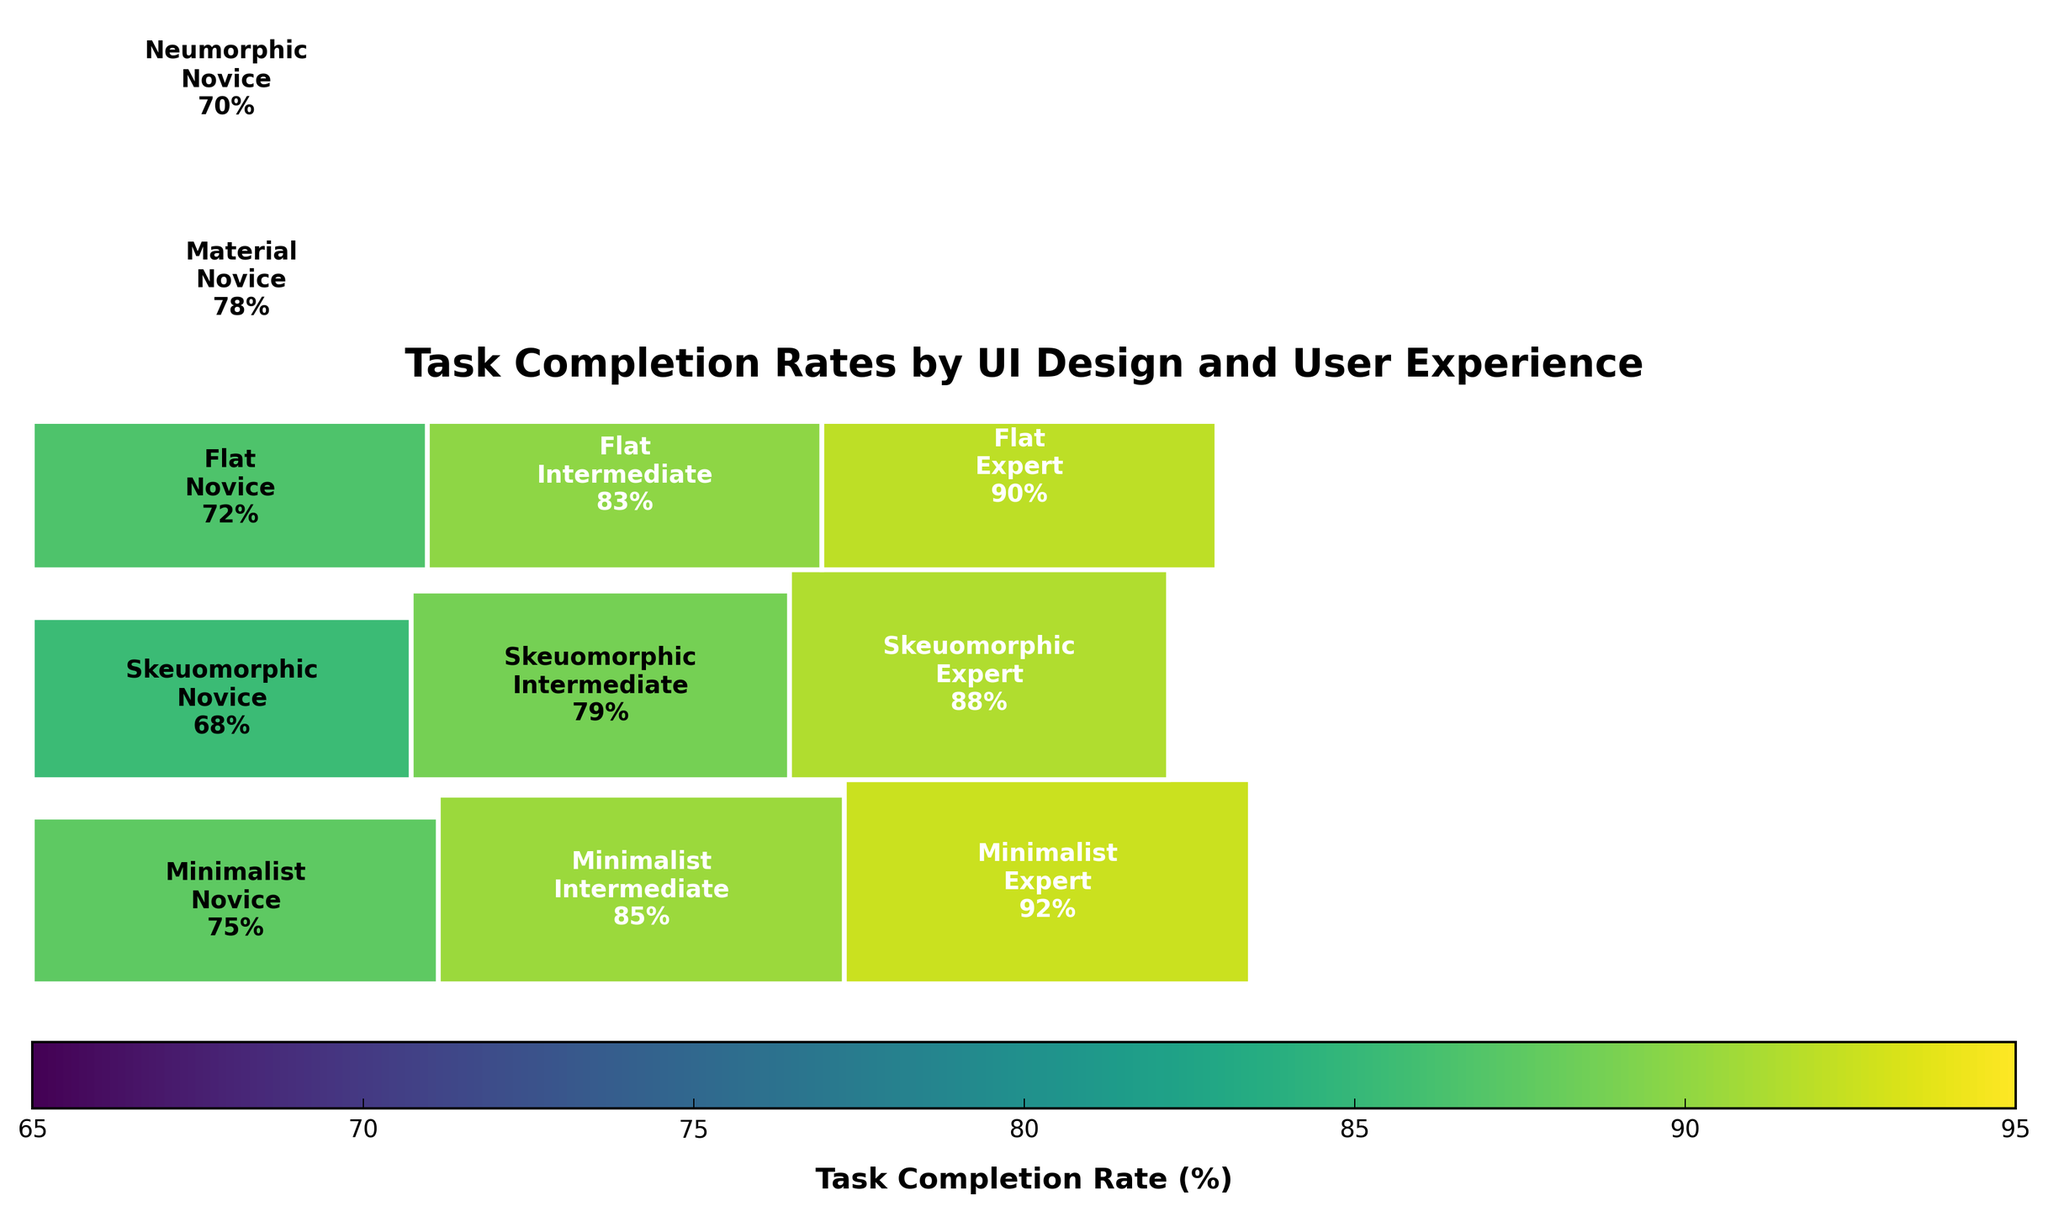What is the title of the mosaic plot? The title of the mosaic plot is displayed at the top of the figure. It helps the viewer understand what the plot is about. In this case, the title is "Task Completion Rates by UI Design and User Experience".
Answer: Task Completion Rates by UI Design and User Experience Which UI design shows the highest task completion rate for novices? To find the highest task completion rate for novices, look at the relevant sections for novice users across different UI designs and compare the values. In this plot, 'Material' has the highest rate for novices at 78%.
Answer: Material Compare the task completion rates for Expert users in Minimalist and Neumorphic UI designs. Which one is higher? Check the segments labeled 'Expert' within both 'Minimalist' and 'Neumorphic' UI designs to compare their task completion rates. Minimalist Experts have a rate of 92%, while Neumorphic Experts have a rate of 89%.
Answer: Minimalist What is the approximate difference in task completion rates between Novice and Expert users for the Skeuomorphic design? Look at the task completion rates of Novice and Expert users within the Skeuomorphic design. Subtract the Novice rate of 68% from the Expert rate of 88% to find the difference.
Answer: 20% Which category has the largest segment in the plot based on task completion rates? The largest segment can be identified by visually examining which rectangle covers the largest area in the plot. The 'Minimalist' design for 'Expert' users, with a task completion rate of 92%, appears largest.
Answer: Minimalist-Expert Is the task completion rate for Intermediate users higher in the Flat design or the Neumorphic design? Locate the 'Intermediate' user segments in both the Flat and Neumorphic designs. Compare their values directly; Flat design shows 83% and Neumorphic 81%.
Answer: Flat How does the task completion rate for Expert users in the Flat design compare to the Material design? Examine the 'Expert' segments in the Flat and Material designs. Flat Experts have a rate of 90%, whereas Material Experts show 94%. The Material design has a higher rate.
Answer: Material What proportion of the total task completion rate does the Skeuomorphic design contribute? Sum the task completion rates for all users in the Skeuomorphic design and divide it by the total completion rate across all designs. The sum is 68 + 79 + 88 = 235. The total rate is 75+85+92+68+79+88+72+83+90+78+87+94+70+81+89 = 1231. So the proportion is 235/1231.
Answer: ~19% Which UI design has the smallest gap between Novice and Expert task completion rates? Calculate the differences between Novice and Expert rates for each UI design and identify the smallest. Minimalist: 17%, Skeuomorphic: 20%, Flat: 18%, Material: 16%, Neumorphic: 19%. Material has the smallest gap (94-78).
Answer: Material 